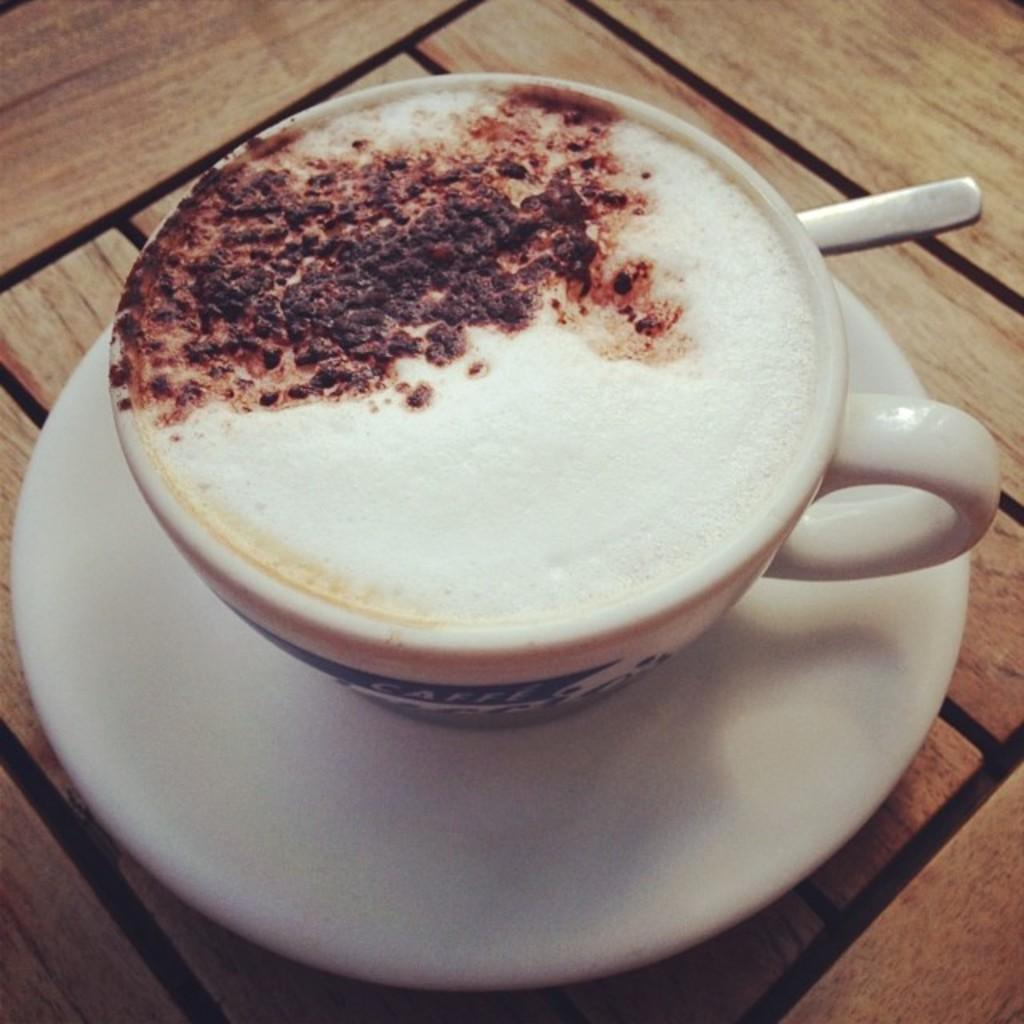What is in the cup that is visible in the image? There is a cup with liquid in the image. What other objects are present in the image? There is a saucer and a spoon visible in the image. On what surface are the objects placed? The objects are placed on a wooden platform. How does the hole in the wooden platform affect the arrangement of the objects? There is no hole present in the wooden platform in the image, so it does not affect the arrangement of the objects. 